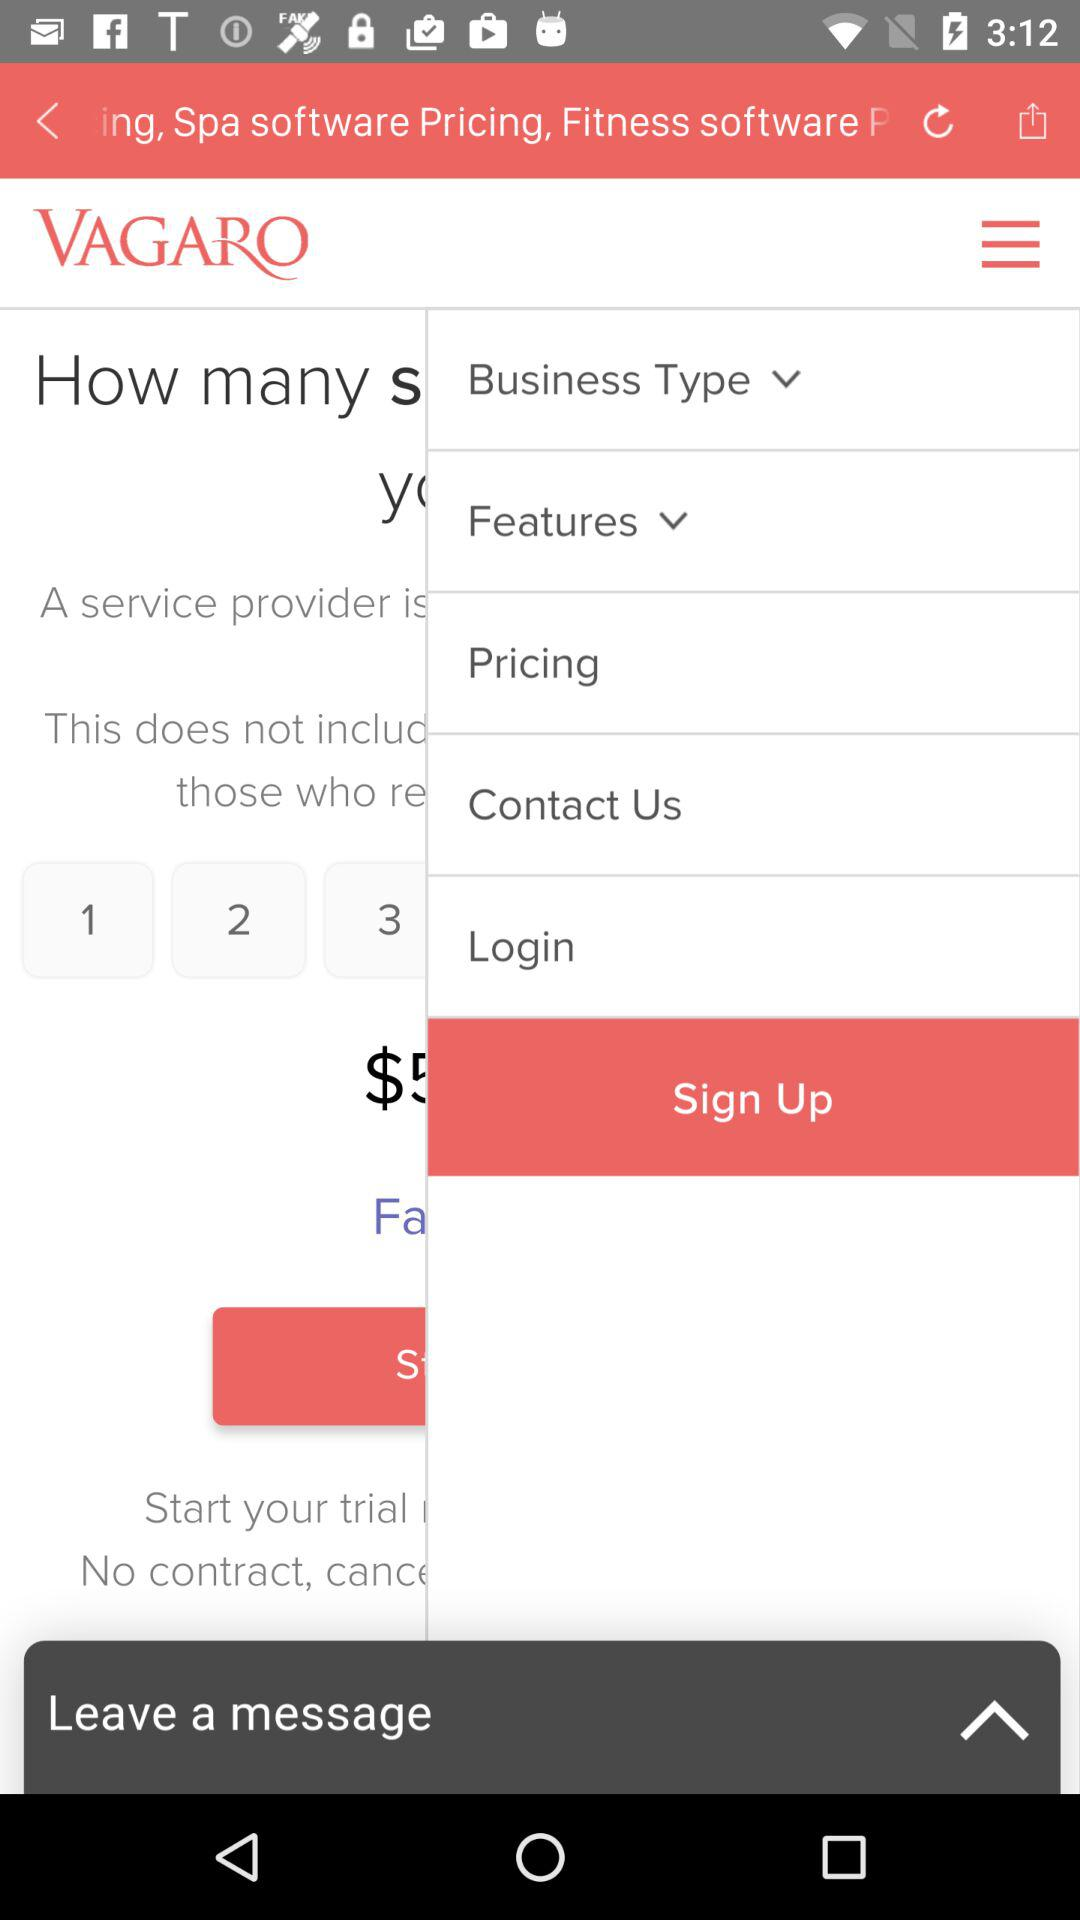What is the name of the application? The name of the application is "VAGARO". 